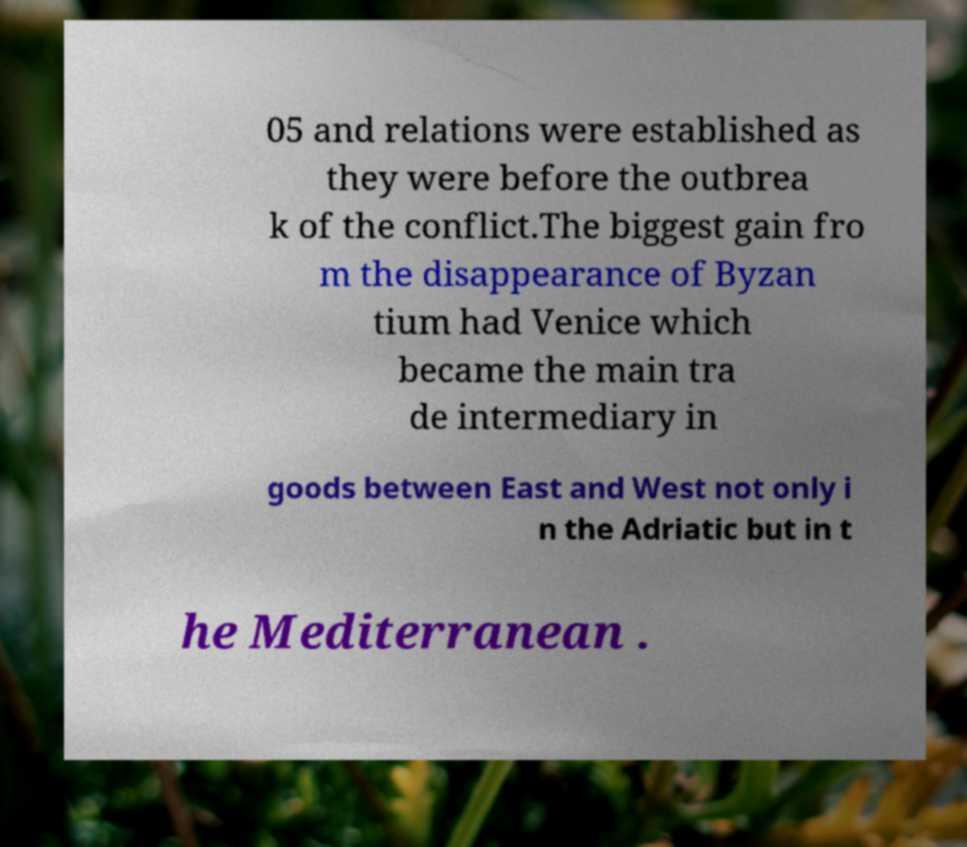Please read and relay the text visible in this image. What does it say? 05 and relations were established as they were before the outbrea k of the conflict.The biggest gain fro m the disappearance of Byzan tium had Venice which became the main tra de intermediary in goods between East and West not only i n the Adriatic but in t he Mediterranean . 